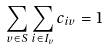Convert formula to latex. <formula><loc_0><loc_0><loc_500><loc_500>\sum _ { v \in S } \sum _ { i \in I _ { v } } c _ { i v } = 1</formula> 